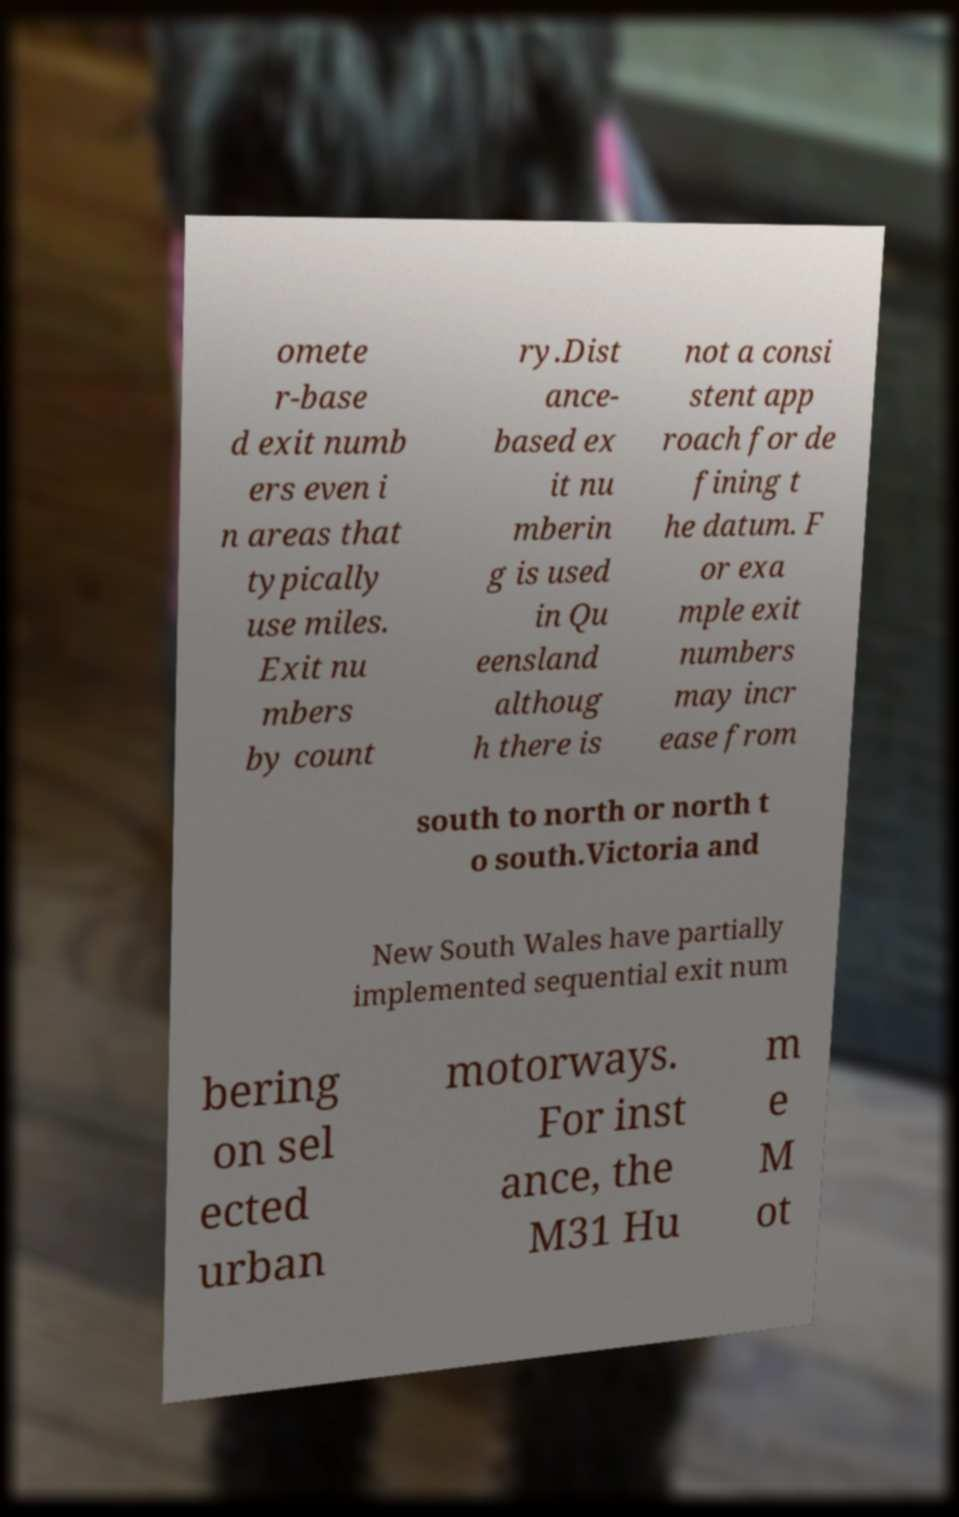Please identify and transcribe the text found in this image. omete r-base d exit numb ers even i n areas that typically use miles. Exit nu mbers by count ry.Dist ance- based ex it nu mberin g is used in Qu eensland althoug h there is not a consi stent app roach for de fining t he datum. F or exa mple exit numbers may incr ease from south to north or north t o south.Victoria and New South Wales have partially implemented sequential exit num bering on sel ected urban motorways. For inst ance, the M31 Hu m e M ot 